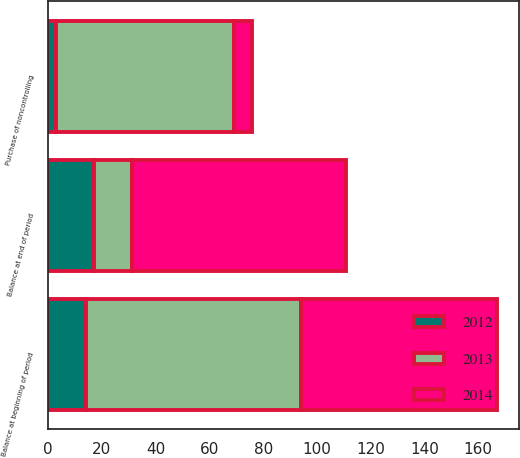Convert chart. <chart><loc_0><loc_0><loc_500><loc_500><stacked_bar_chart><ecel><fcel>Balance at beginning of period<fcel>Purchase of noncontrolling<fcel>Balance at end of period<nl><fcel>2012<fcel>14<fcel>3<fcel>17<nl><fcel>2013<fcel>80<fcel>66<fcel>14<nl><fcel>2014<fcel>73<fcel>7<fcel>80<nl></chart> 